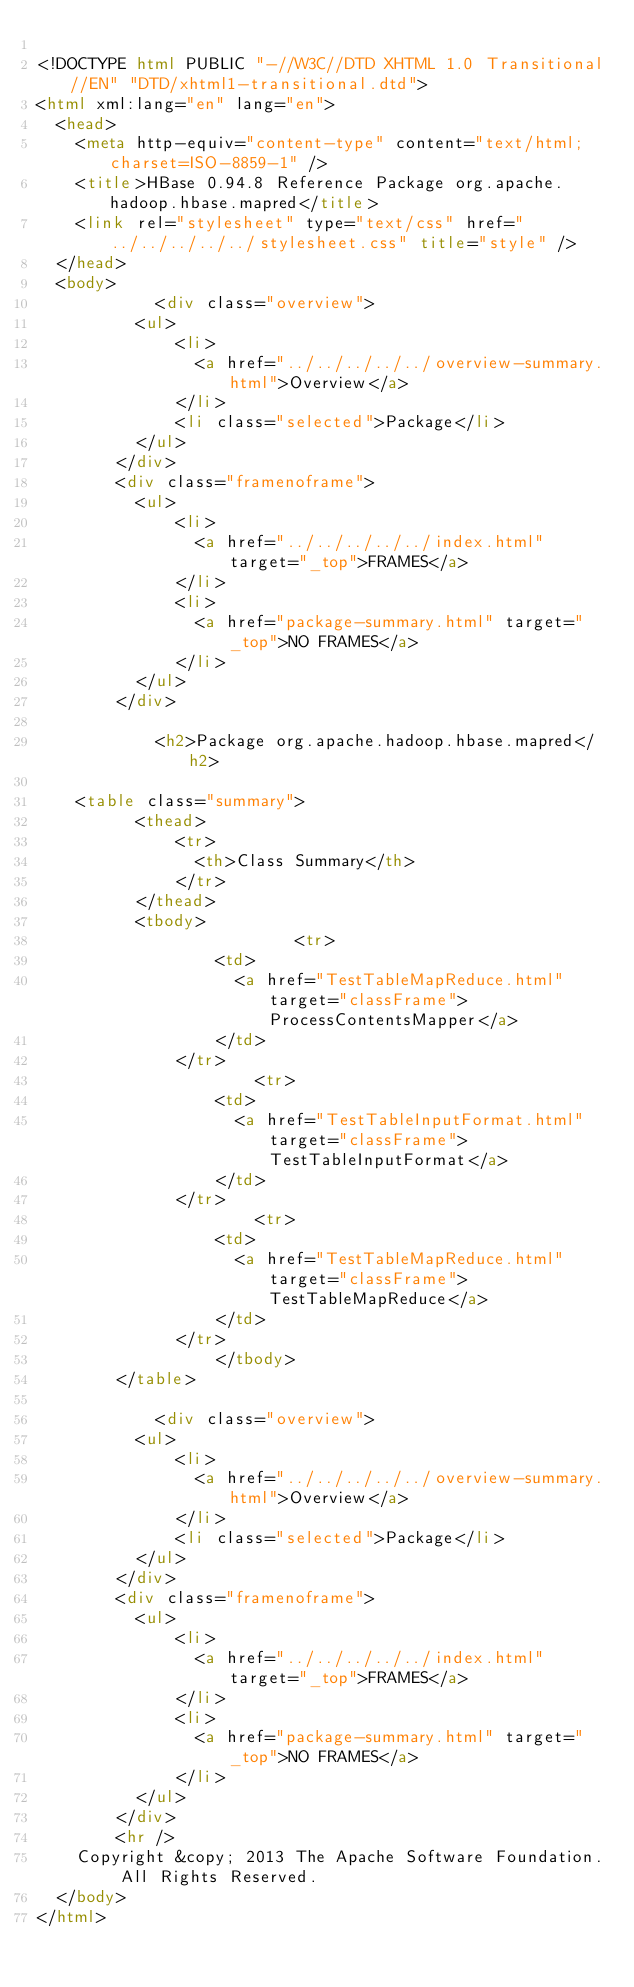<code> <loc_0><loc_0><loc_500><loc_500><_HTML_>
<!DOCTYPE html PUBLIC "-//W3C//DTD XHTML 1.0 Transitional//EN" "DTD/xhtml1-transitional.dtd">
<html xml:lang="en" lang="en">
	<head>
		<meta http-equiv="content-type" content="text/html; charset=ISO-8859-1" />
		<title>HBase 0.94.8 Reference Package org.apache.hadoop.hbase.mapred</title>
		<link rel="stylesheet" type="text/css" href="../../../../../stylesheet.css" title="style" />
	</head>
	<body>
		      	<div class="overview">
        	<ul>
          		<li>
            		<a href="../../../../../overview-summary.html">Overview</a>
          		</li>
          		<li class="selected">Package</li>
        	</ul>
      	</div>
      	<div class="framenoframe">
        	<ul>
          		<li>
            		<a href="../../../../../index.html" target="_top">FRAMES</a>
          		</li>
          		<li>
            		<a href="package-summary.html" target="_top">NO FRAMES</a>
          		</li>
        	</ul>
      	</div>
		
		      	<h2>Package org.apache.hadoop.hbase.mapred</h2>

		<table class="summary">
        	<thead>
          		<tr>
            		<th>Class Summary</th>
          		</tr>
        	</thead>
        	<tbody>
        		            	<tr>
              		<td>
                		<a href="TestTableMapReduce.html" target="classFrame">ProcessContentsMapper</a>
              		</td>
            	</tr>
				            	<tr>
              		<td>
                		<a href="TestTableInputFormat.html" target="classFrame">TestTableInputFormat</a>
              		</td>
            	</tr>
				            	<tr>
              		<td>
                		<a href="TestTableMapReduce.html" target="classFrame">TestTableMapReduce</a>
              		</td>
            	</tr>
				        	</tbody>
      	</table>
		
		      	<div class="overview">
        	<ul>
          		<li>
            		<a href="../../../../../overview-summary.html">Overview</a>
          		</li>
          		<li class="selected">Package</li>
        	</ul>
      	</div>
      	<div class="framenoframe">
        	<ul>
          		<li>
            		<a href="../../../../../index.html" target="_top">FRAMES</a>
          		</li>
          		<li>
            		<a href="package-summary.html" target="_top">NO FRAMES</a>
          		</li>
        	</ul>
      	</div>
				<hr />
		Copyright &copy; 2013 The Apache Software Foundation. All Rights Reserved.
	</body>
</html></code> 